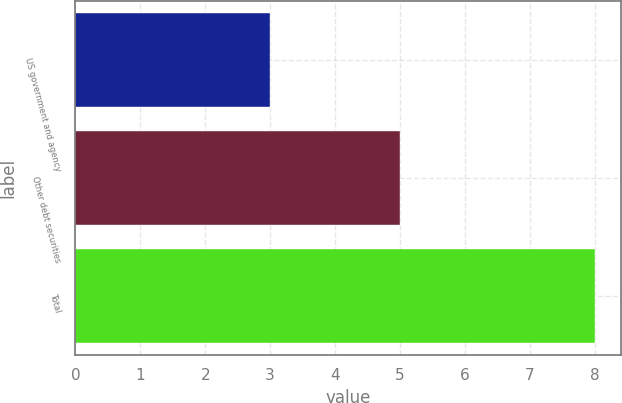Convert chart to OTSL. <chart><loc_0><loc_0><loc_500><loc_500><bar_chart><fcel>US government and agency<fcel>Other debt securities<fcel>Total<nl><fcel>3<fcel>5<fcel>8<nl></chart> 